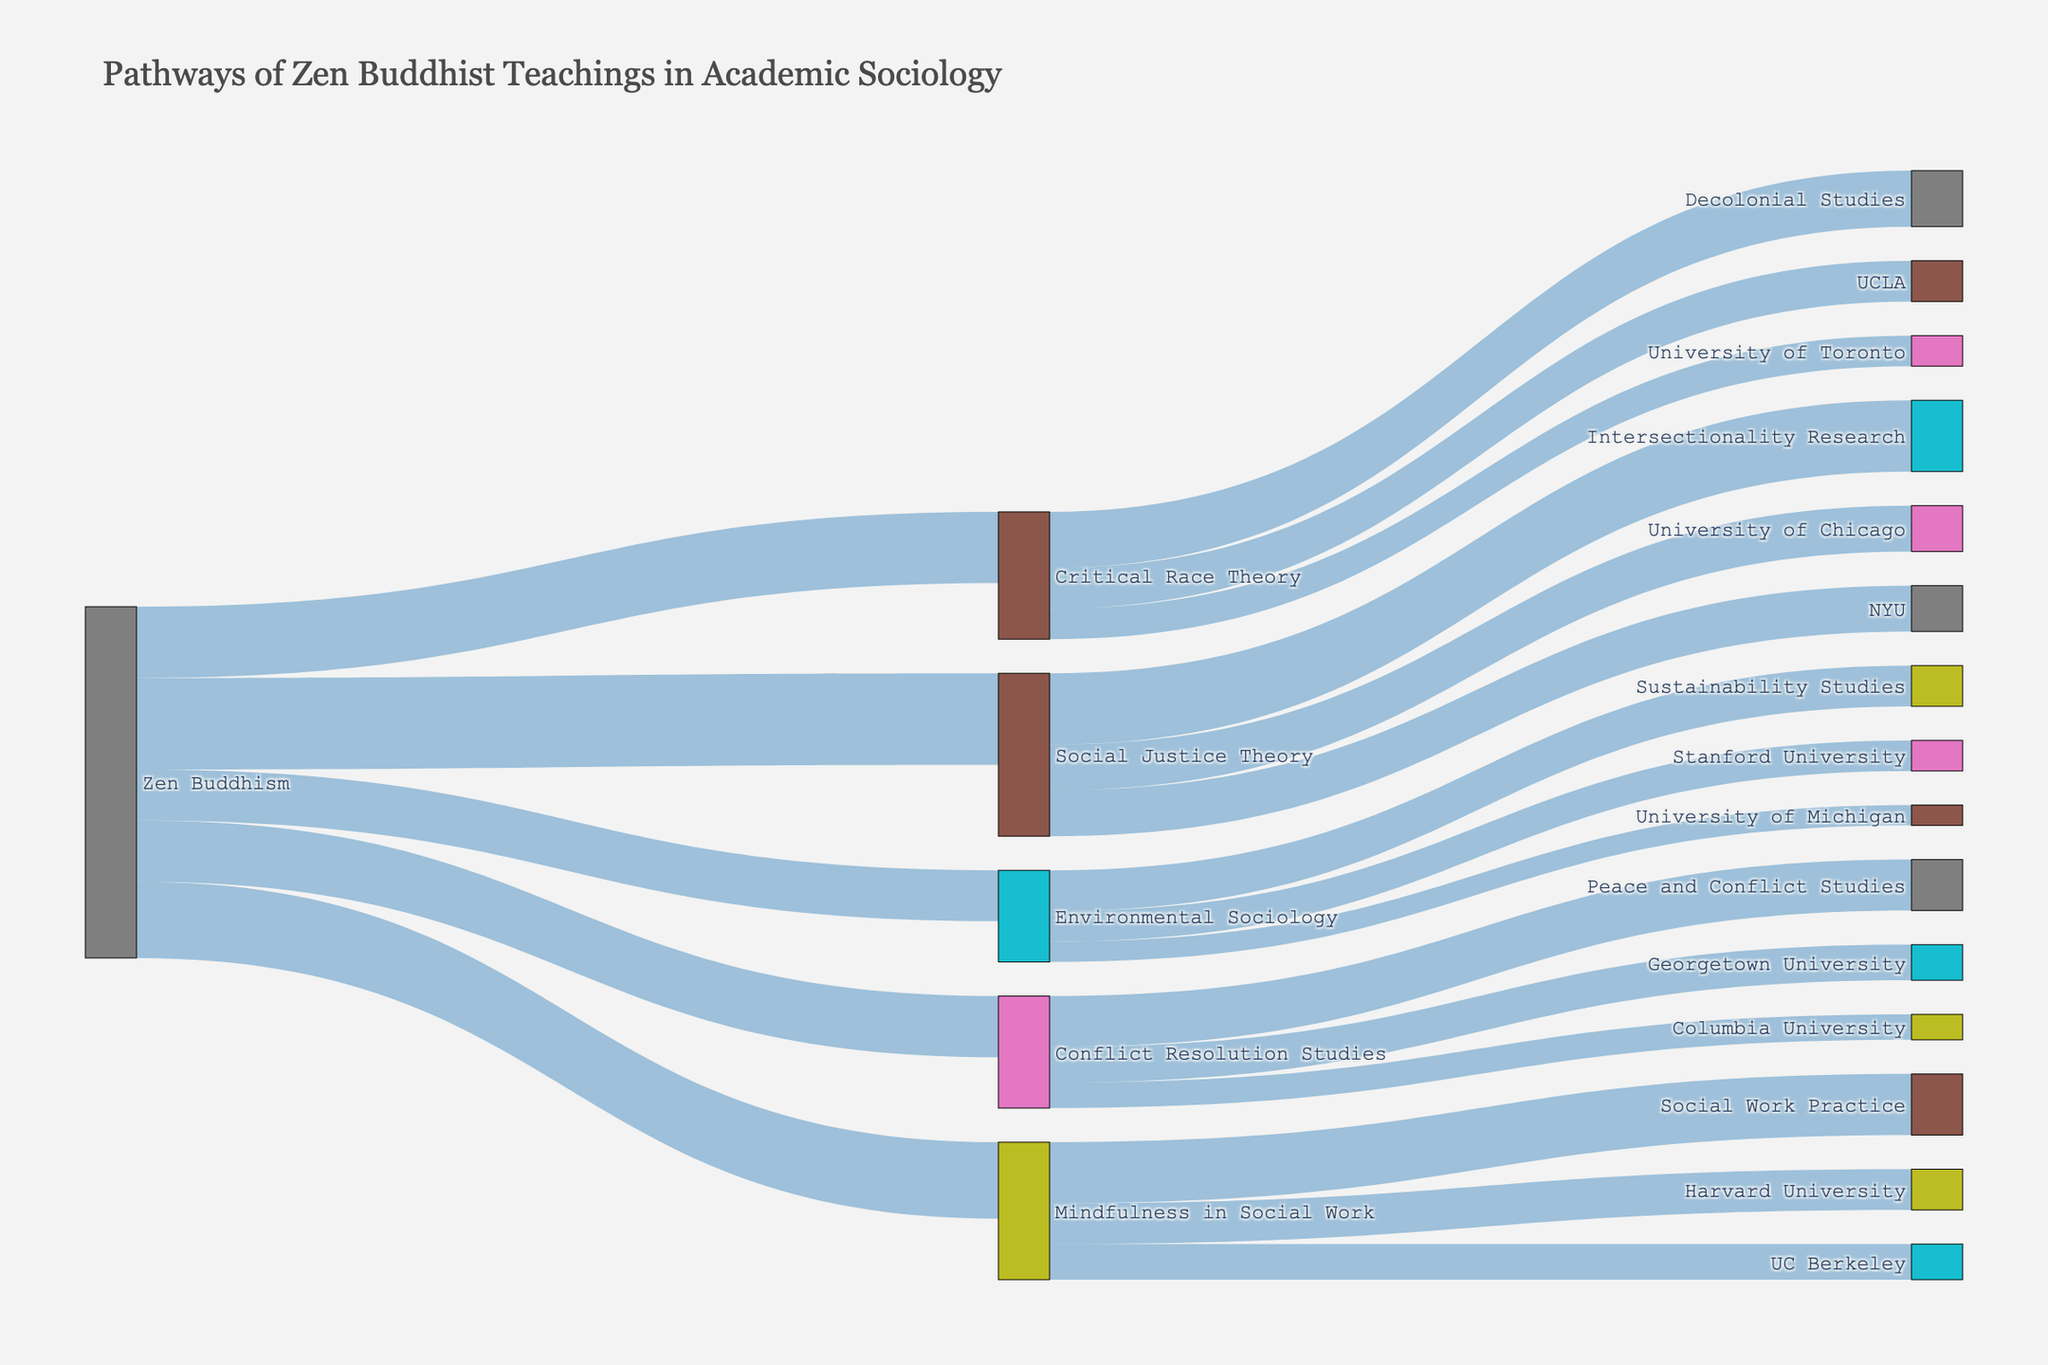what is the title of the figure? The title is typically displayed at the top of the figure and summarizes its content briefly. In this case, it reads "Pathways of Zen Buddhist Teachings in Academic Sociology".
Answer: Pathways of Zen Buddhist Teachings in Academic Sociology How many universities have adopted "Social Justice Theory" into their curricula? Count the number of target nodes directly connected to "Social Justice Theory".
Answer: 2 Which university has the highest adoption rate for "Mindfulness in Social Work"? Compare the values corresponding to the universities connected to "Mindfulness in Social Work" and identify the one with the highest value. Harvard University (8) and UC Berkeley (7).
Answer: Harvard University What is the total number of courses stemming from "Zen Buddhism"? Add up the values connecting "Zen Buddhism" to various courses: Mindfulness in Social Work (15), Environmental Sociology (10), Conflict Resolution Studies (12), Social Justice Theory (18), and Critical Race Theory (14). Calculation: 15 + 10 + 12 + 18 + 14.
Answer: 69 Between "Critical Race Theory" and "Social Justice Theory," which has more courses directly stemming from it? Identify the target nodes (courses) directly stemming from each and count them. Critical Race Theory has Decolonial Studies and UCLA and University of Toronto. Social Justice Theory has NYU, University of Chicago, and Intersectionality Research.
Answer: Social Justice Theory What is the value of the smallest course adoption connected to "Zen Buddhism"? Identify the smallest value among the targets directly connected to "Zen Buddhism": 15, 10, 12, 18, and 14.
Answer: 10 Which course has the most university adoption rates connected to "Zen Buddhism"? Among the courses connecting to multiple universities, find the one connected to the highest number of universities: "Mindfulness in Social Work" has Harvard University and UC Berkeley. "Environmental Sociology" has Stanford University and University of Michigan.
Answer: Mindfulness in Social Work By how much does the adoption rate of "Mindfulness in Social Work" by Harvard University exceed that of UC Berkeley? Subtract the value for UC Berkeley from that of Harvard University: 8 - 7.
Answer: 1 How many distinctive courses link directly from "Conflict Resolution Studies"? Count the number of distinct target nodes directly linked from "Conflict Resolution Studies": Columbia University, Georgetown University, and Peace and Conflict Studies.
Answer: 3 What university has an equal adoption rate of courses stemming from "Zen Buddhism" into the "Critical Race Theory"? Compare the values connected to the target nodes under "Critical Race Theory": UCLA (8) and University of Toronto (6) have no equal adoption rates.
Answer: None 